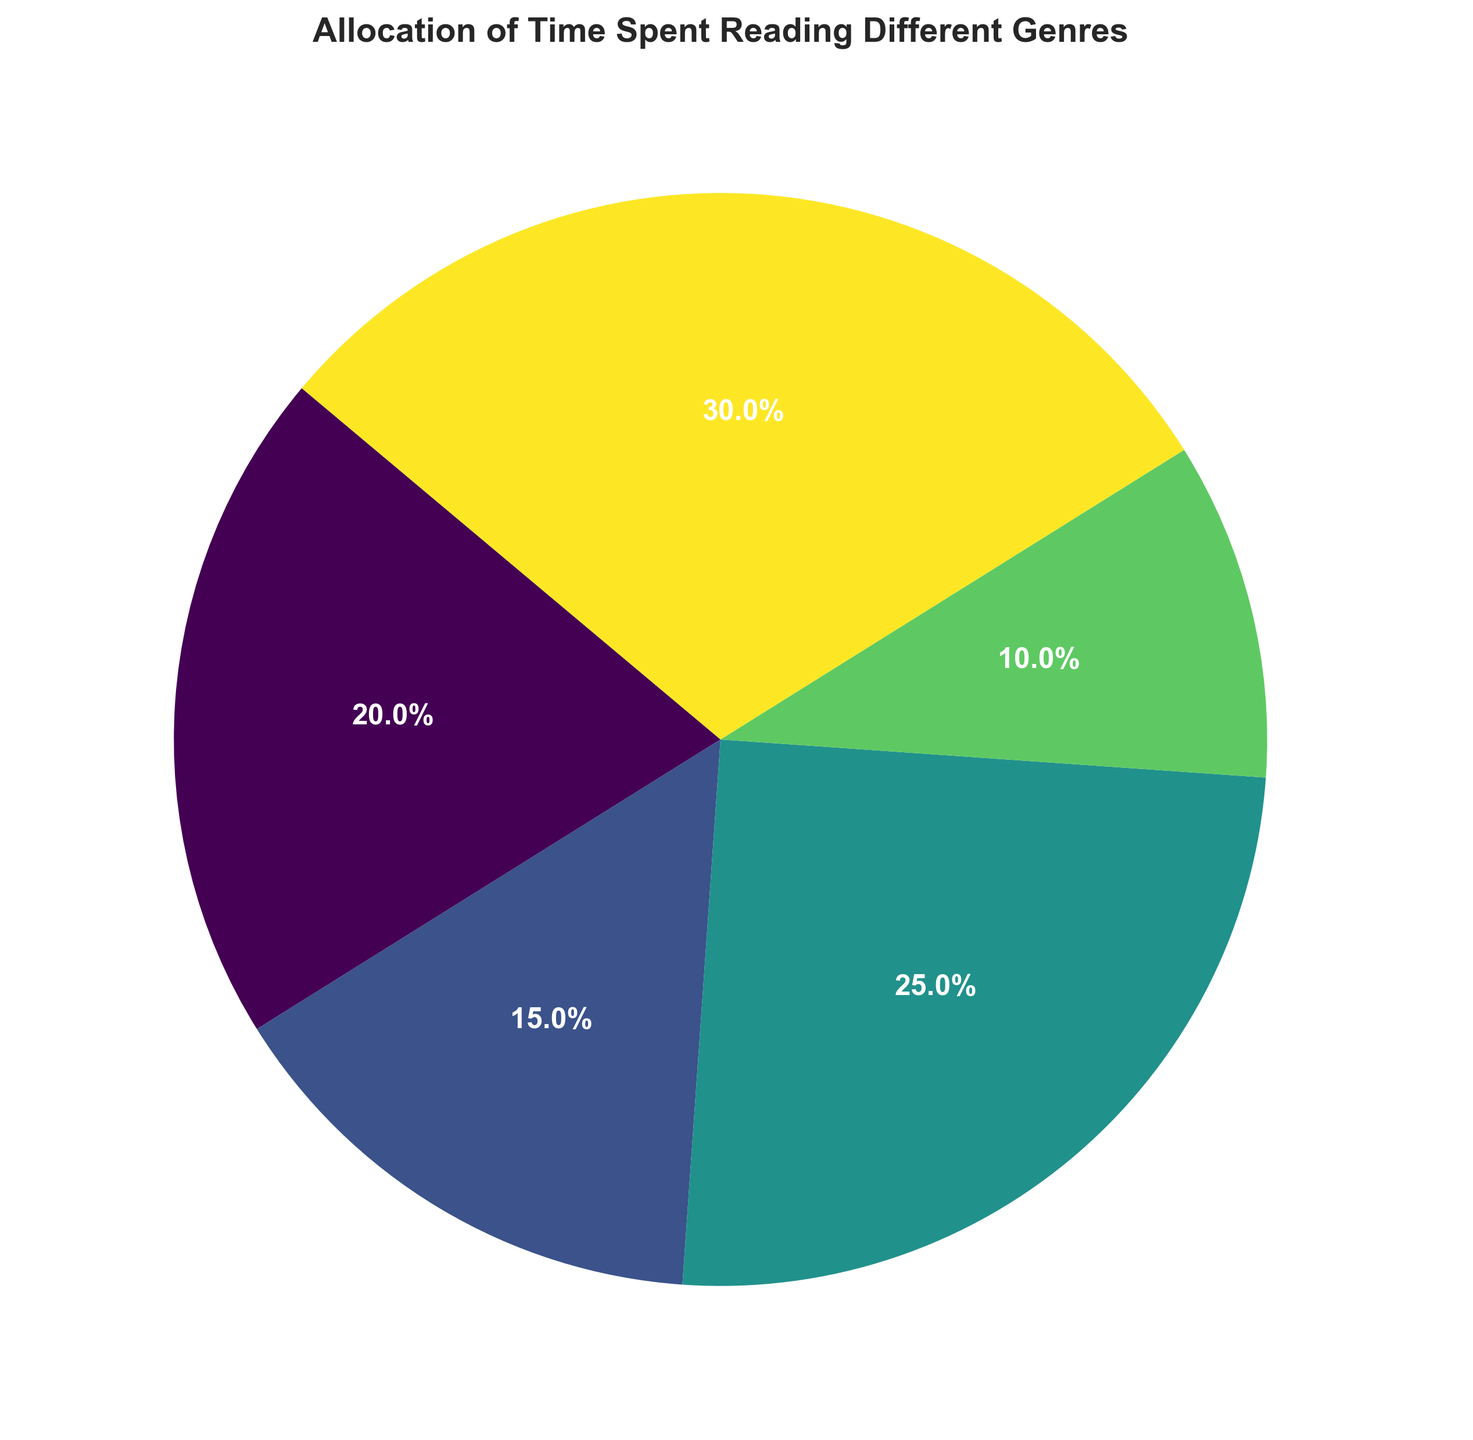Which genre had the largest proportion of time spent reading? According to the pie chart, Comics had the largest proportion of time spent reading as it occupied the biggest slice of the pie.
Answer: Comics What is the combined time spent reading Fantasy and Science Fiction? The time spent reading Fantasy is 20 hours and Science Fiction is 15 hours. Adding these together, 20 + 15 equals 35 hours.
Answer: 35 hours Which genre had the least amount of time spent reading? Educational had the least amount of time spent reading, as indicated by the smallest slice in the pie chart.
Answer: Educational How much more time was spent reading Comics compared to Educational? Time spent on Comics is 30 hours, while Educational is 10 hours. The difference is 30 - 10, which equals 20 hours.
Answer: 20 hours What percentage of the total time was spent reading Adventure? The total time spent on all genres is 100 hours. The time spent on Adventure is 25 hours. The percentage is (25/100) * 100%, which equals 25%.
Answer: 25% Is the time spent reading Fantasy greater than or less than the time spent reading Science Fiction? The time spent reading Fantasy is 20 hours and Science Fiction is 15 hours. Since 20 is greater than 15, Fantasy has more time spent.
Answer: Greater Which two genres combined make up more than half of the total reading time? Comics (30 hours) and Adventure (25 hours) together equal 55 hours, which is more than half of the total 100 hours.
Answer: Comics and Adventure Rank the genres in decreasing order of time spent reading. Time spent: Comics (30 hours), Adventure (25 hours), Fantasy (20 hours), Science Fiction (15 hours), Educational (10 hours). The decreasing order is Comics, Adventure, Fantasy, Science Fiction, and Educational.
Answer: Comics, Adventure, Fantasy, Science Fiction, Educational If another 10 hours were spent on Educational, would it have more time spent than Fantasy? Currently, Educational has 10 hours. Adding 10 more hours would make it 20 hours. Fantasy already has 20 hours. Thus, Educational and Fantasy would have equal time spent.
Answer: Equal 